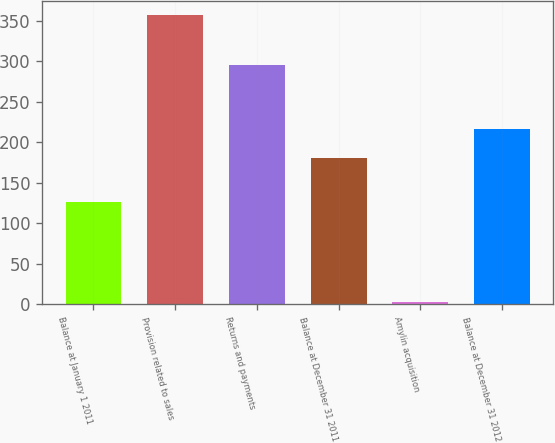Convert chart. <chart><loc_0><loc_0><loc_500><loc_500><bar_chart><fcel>Balance at January 1 2011<fcel>Provision related to sales<fcel>Returns and payments<fcel>Balance at December 31 2011<fcel>Amylin acquisition<fcel>Balance at December 31 2012<nl><fcel>127<fcel>357<fcel>296<fcel>181<fcel>3<fcel>216.4<nl></chart> 